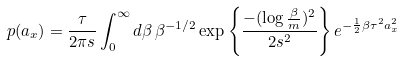Convert formula to latex. <formula><loc_0><loc_0><loc_500><loc_500>p ( a _ { x } ) = \frac { \tau } { 2 \pi s } \int _ { 0 } ^ { \infty } d \beta \, \beta ^ { - 1 / 2 } \exp \left \{ \frac { - ( \log \frac { \beta } { m } ) ^ { 2 } } { 2 s ^ { 2 } } \right \} e ^ { - \frac { 1 } { 2 } \beta \tau ^ { 2 } a _ { x } ^ { 2 } }</formula> 